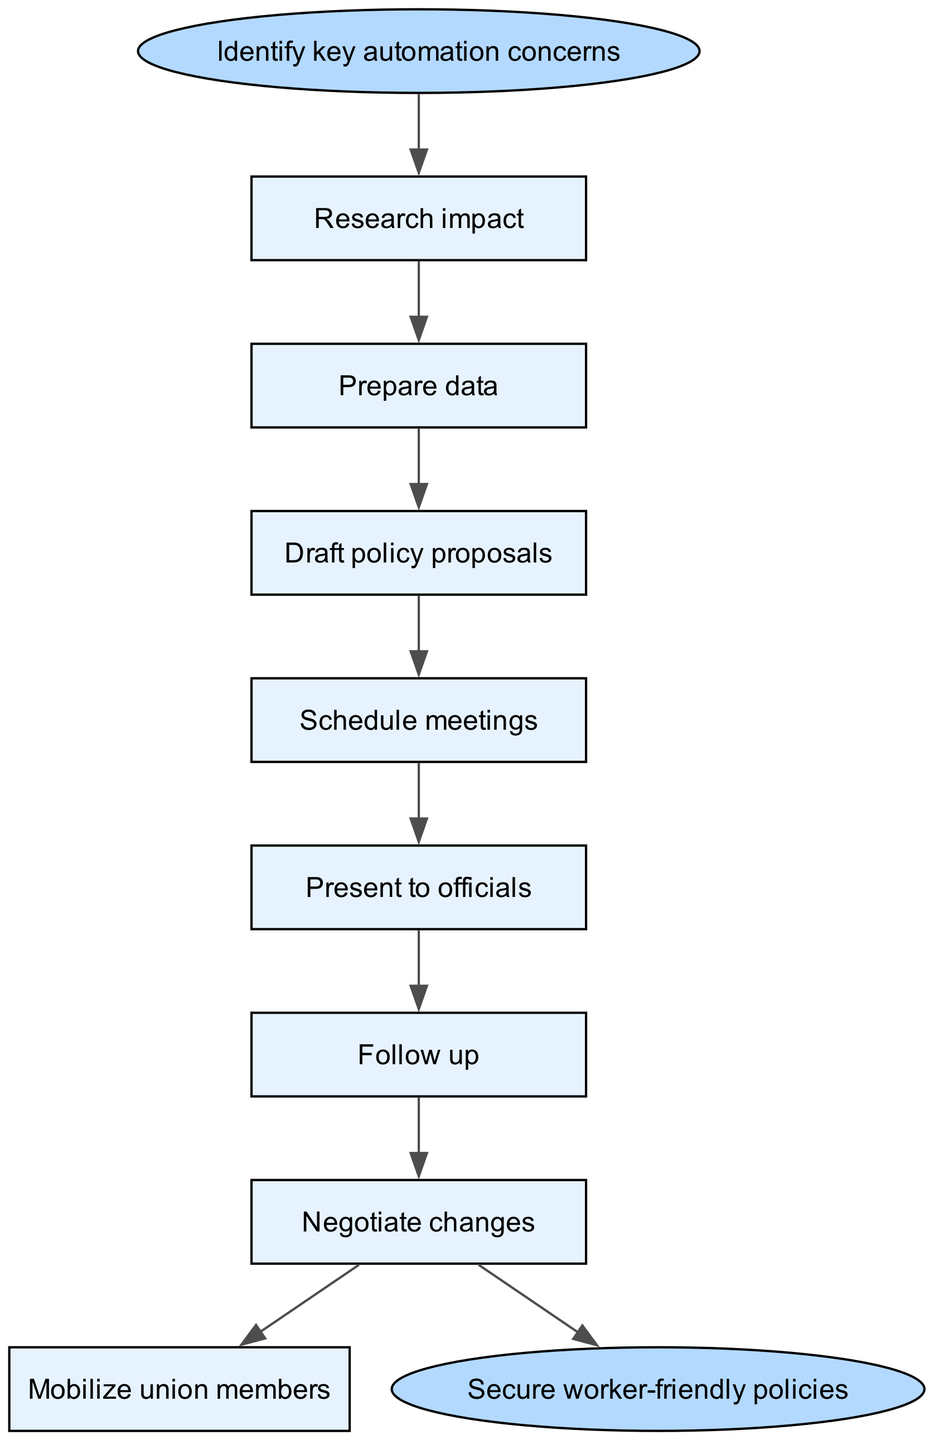What is the first step in the lobbying process? The first step in the process is provided as the starting point in the diagram, which clearly states "Identify key automation concerns".
Answer: Identify key automation concerns How many steps are there in total? By counting the individual process steps listed between the start and end nodes, there are 7 distinct steps shown in the diagram.
Answer: 7 What is the last action taken before securing worker-friendly policies? The last action in the sequence before reaching the endpoint 'Secure worker-friendly policies' is 'Mobilize union members', which is the final step in the flow.
Answer: Mobilize union members What step follows 'Schedule meetings'? The flow of the diagram indicates that the step immediately following 'Schedule meetings' is 'Present to officials', establishing a clear direction of progress.
Answer: Present to officials Which step directly leads to negotiations? After 'Follow up', the next logical step that leads into negotiations is 'Negotiate changes', indicating a progression toward addressing concerns through negotiation.
Answer: Negotiate changes How does the process start? The process begins with a clear identification of automation concerns, which is stated as the starting point and sets the foundation for all subsequent actions in the diagram.
Answer: Identify key automation concerns What is the objective of this entire procedure? The endpoint of the diagram encapsulates the main goal of the lobbying process, which is to establish 'Secure worker-friendly policies' as the desired outcome of all the preceding actions.
Answer: Secure worker-friendly policies What is the relationship between 'Draft policy proposals' and 'Schedule meetings'? 'Draft policy proposals' directly precedes 'Schedule meetings', indicating that the drafting of proposals is a prerequisite for scheduling discussions with officials.
Answer: Draft policy proposals leads to Schedule meetings 